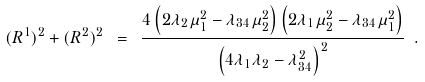<formula> <loc_0><loc_0><loc_500><loc_500>( R ^ { 1 } ) ^ { 2 } + ( R ^ { 2 } ) ^ { 2 } \ = \ \frac { 4 \left ( 2 \lambda _ { 2 } \mu _ { 1 } ^ { 2 } - \lambda _ { 3 4 } \mu _ { 2 } ^ { 2 } \right ) \left ( 2 \lambda _ { 1 } \mu _ { 2 } ^ { 2 } - \lambda _ { 3 4 } \mu _ { 1 } ^ { 2 } \right ) } { \left ( 4 \lambda _ { 1 } \lambda _ { 2 } - \lambda _ { 3 4 } ^ { 2 } \right ) ^ { 2 } } \ .</formula> 